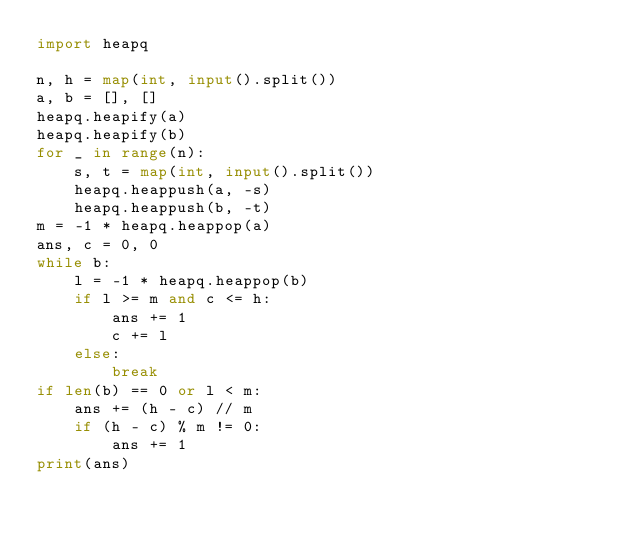<code> <loc_0><loc_0><loc_500><loc_500><_Python_>import heapq

n, h = map(int, input().split())
a, b = [], []
heapq.heapify(a)
heapq.heapify(b)
for _ in range(n):
    s, t = map(int, input().split())
    heapq.heappush(a, -s)
    heapq.heappush(b, -t)
m = -1 * heapq.heappop(a)
ans, c = 0, 0
while b:
    l = -1 * heapq.heappop(b)
    if l >= m and c <= h:
        ans += 1
        c += l
    else:
        break
if len(b) == 0 or l < m:
    ans += (h - c) // m
    if (h - c) % m != 0:
        ans += 1
print(ans)</code> 